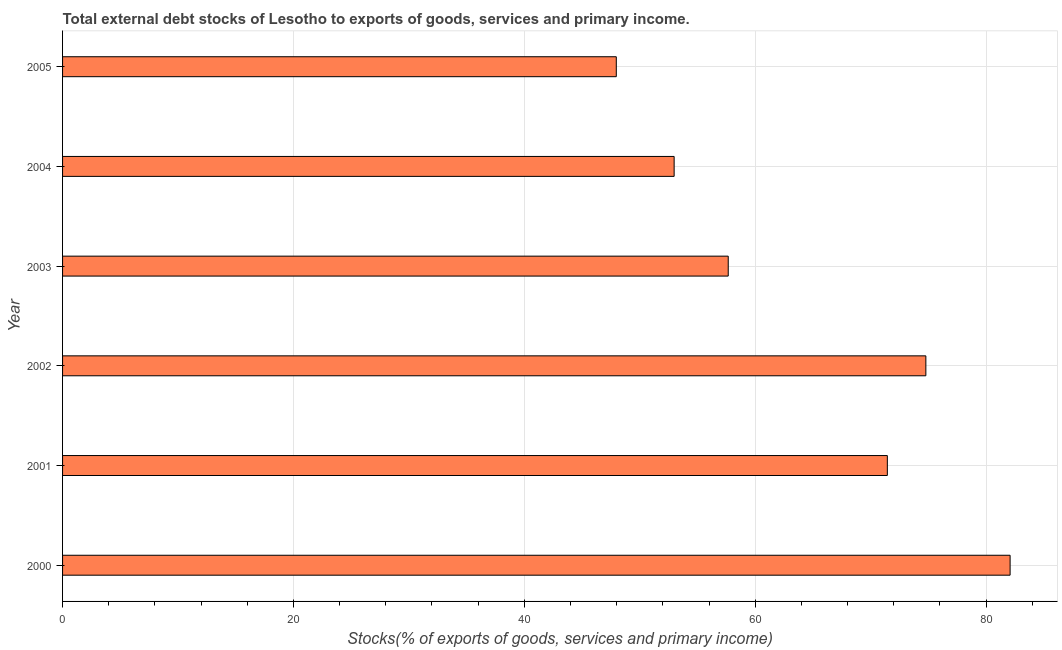Does the graph contain any zero values?
Provide a short and direct response. No. What is the title of the graph?
Provide a succinct answer. Total external debt stocks of Lesotho to exports of goods, services and primary income. What is the label or title of the X-axis?
Keep it short and to the point. Stocks(% of exports of goods, services and primary income). What is the label or title of the Y-axis?
Your answer should be compact. Year. What is the external debt stocks in 2002?
Make the answer very short. 74.78. Across all years, what is the maximum external debt stocks?
Ensure brevity in your answer.  82.08. Across all years, what is the minimum external debt stocks?
Provide a short and direct response. 47.97. In which year was the external debt stocks maximum?
Your answer should be very brief. 2000. What is the sum of the external debt stocks?
Offer a very short reply. 386.91. What is the difference between the external debt stocks in 2000 and 2001?
Provide a succinct answer. 10.63. What is the average external debt stocks per year?
Offer a terse response. 64.48. What is the median external debt stocks?
Provide a short and direct response. 64.55. Do a majority of the years between 2002 and 2001 (inclusive) have external debt stocks greater than 28 %?
Make the answer very short. No. What is the ratio of the external debt stocks in 2001 to that in 2003?
Ensure brevity in your answer.  1.24. Is the external debt stocks in 2002 less than that in 2004?
Ensure brevity in your answer.  No. Is the difference between the external debt stocks in 2000 and 2002 greater than the difference between any two years?
Your response must be concise. No. What is the difference between the highest and the second highest external debt stocks?
Offer a very short reply. 7.3. What is the difference between the highest and the lowest external debt stocks?
Ensure brevity in your answer.  34.11. How many years are there in the graph?
Give a very brief answer. 6. What is the difference between two consecutive major ticks on the X-axis?
Provide a short and direct response. 20. Are the values on the major ticks of X-axis written in scientific E-notation?
Make the answer very short. No. What is the Stocks(% of exports of goods, services and primary income) in 2000?
Ensure brevity in your answer.  82.08. What is the Stocks(% of exports of goods, services and primary income) of 2001?
Provide a short and direct response. 71.44. What is the Stocks(% of exports of goods, services and primary income) in 2002?
Ensure brevity in your answer.  74.78. What is the Stocks(% of exports of goods, services and primary income) in 2003?
Offer a terse response. 57.66. What is the Stocks(% of exports of goods, services and primary income) in 2004?
Give a very brief answer. 52.98. What is the Stocks(% of exports of goods, services and primary income) in 2005?
Provide a succinct answer. 47.97. What is the difference between the Stocks(% of exports of goods, services and primary income) in 2000 and 2001?
Offer a terse response. 10.63. What is the difference between the Stocks(% of exports of goods, services and primary income) in 2000 and 2002?
Offer a very short reply. 7.3. What is the difference between the Stocks(% of exports of goods, services and primary income) in 2000 and 2003?
Your answer should be very brief. 24.42. What is the difference between the Stocks(% of exports of goods, services and primary income) in 2000 and 2004?
Give a very brief answer. 29.1. What is the difference between the Stocks(% of exports of goods, services and primary income) in 2000 and 2005?
Your answer should be very brief. 34.11. What is the difference between the Stocks(% of exports of goods, services and primary income) in 2001 and 2002?
Your answer should be very brief. -3.34. What is the difference between the Stocks(% of exports of goods, services and primary income) in 2001 and 2003?
Offer a terse response. 13.78. What is the difference between the Stocks(% of exports of goods, services and primary income) in 2001 and 2004?
Offer a very short reply. 18.47. What is the difference between the Stocks(% of exports of goods, services and primary income) in 2001 and 2005?
Keep it short and to the point. 23.48. What is the difference between the Stocks(% of exports of goods, services and primary income) in 2002 and 2003?
Provide a short and direct response. 17.12. What is the difference between the Stocks(% of exports of goods, services and primary income) in 2002 and 2004?
Offer a very short reply. 21.8. What is the difference between the Stocks(% of exports of goods, services and primary income) in 2002 and 2005?
Keep it short and to the point. 26.81. What is the difference between the Stocks(% of exports of goods, services and primary income) in 2003 and 2004?
Provide a succinct answer. 4.69. What is the difference between the Stocks(% of exports of goods, services and primary income) in 2003 and 2005?
Your answer should be compact. 9.7. What is the difference between the Stocks(% of exports of goods, services and primary income) in 2004 and 2005?
Offer a very short reply. 5.01. What is the ratio of the Stocks(% of exports of goods, services and primary income) in 2000 to that in 2001?
Ensure brevity in your answer.  1.15. What is the ratio of the Stocks(% of exports of goods, services and primary income) in 2000 to that in 2002?
Keep it short and to the point. 1.1. What is the ratio of the Stocks(% of exports of goods, services and primary income) in 2000 to that in 2003?
Your response must be concise. 1.42. What is the ratio of the Stocks(% of exports of goods, services and primary income) in 2000 to that in 2004?
Ensure brevity in your answer.  1.55. What is the ratio of the Stocks(% of exports of goods, services and primary income) in 2000 to that in 2005?
Keep it short and to the point. 1.71. What is the ratio of the Stocks(% of exports of goods, services and primary income) in 2001 to that in 2002?
Give a very brief answer. 0.95. What is the ratio of the Stocks(% of exports of goods, services and primary income) in 2001 to that in 2003?
Provide a succinct answer. 1.24. What is the ratio of the Stocks(% of exports of goods, services and primary income) in 2001 to that in 2004?
Provide a short and direct response. 1.35. What is the ratio of the Stocks(% of exports of goods, services and primary income) in 2001 to that in 2005?
Offer a terse response. 1.49. What is the ratio of the Stocks(% of exports of goods, services and primary income) in 2002 to that in 2003?
Offer a terse response. 1.3. What is the ratio of the Stocks(% of exports of goods, services and primary income) in 2002 to that in 2004?
Your answer should be compact. 1.41. What is the ratio of the Stocks(% of exports of goods, services and primary income) in 2002 to that in 2005?
Your response must be concise. 1.56. What is the ratio of the Stocks(% of exports of goods, services and primary income) in 2003 to that in 2004?
Your response must be concise. 1.09. What is the ratio of the Stocks(% of exports of goods, services and primary income) in 2003 to that in 2005?
Your response must be concise. 1.2. What is the ratio of the Stocks(% of exports of goods, services and primary income) in 2004 to that in 2005?
Offer a very short reply. 1.1. 